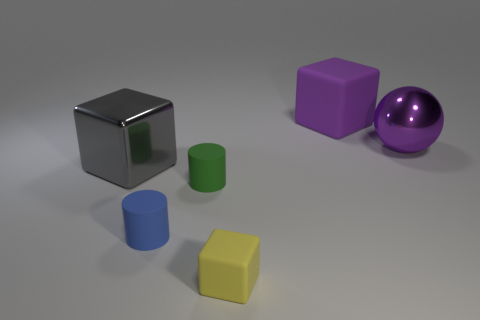Does the big rubber block have the same color as the big sphere?
Offer a very short reply. Yes. There is a matte object that is the same color as the metal sphere; what shape is it?
Provide a succinct answer. Cube. How many purple rubber cubes have the same size as the blue matte cylinder?
Your response must be concise. 0. Are the big sphere and the big block that is left of the tiny yellow matte thing made of the same material?
Offer a terse response. Yes. Is the number of large gray cubes less than the number of big brown metallic balls?
Your response must be concise. No. Is there anything else of the same color as the large sphere?
Your answer should be compact. Yes. What is the shape of the green thing that is the same material as the tiny block?
Offer a very short reply. Cylinder. There is a small thing to the left of the green cylinder that is behind the blue thing; how many tiny green cylinders are in front of it?
Provide a succinct answer. 0. The thing that is both behind the blue thing and in front of the gray shiny block has what shape?
Keep it short and to the point. Cylinder. Are there fewer things on the right side of the blue matte thing than big spheres?
Make the answer very short. No. 